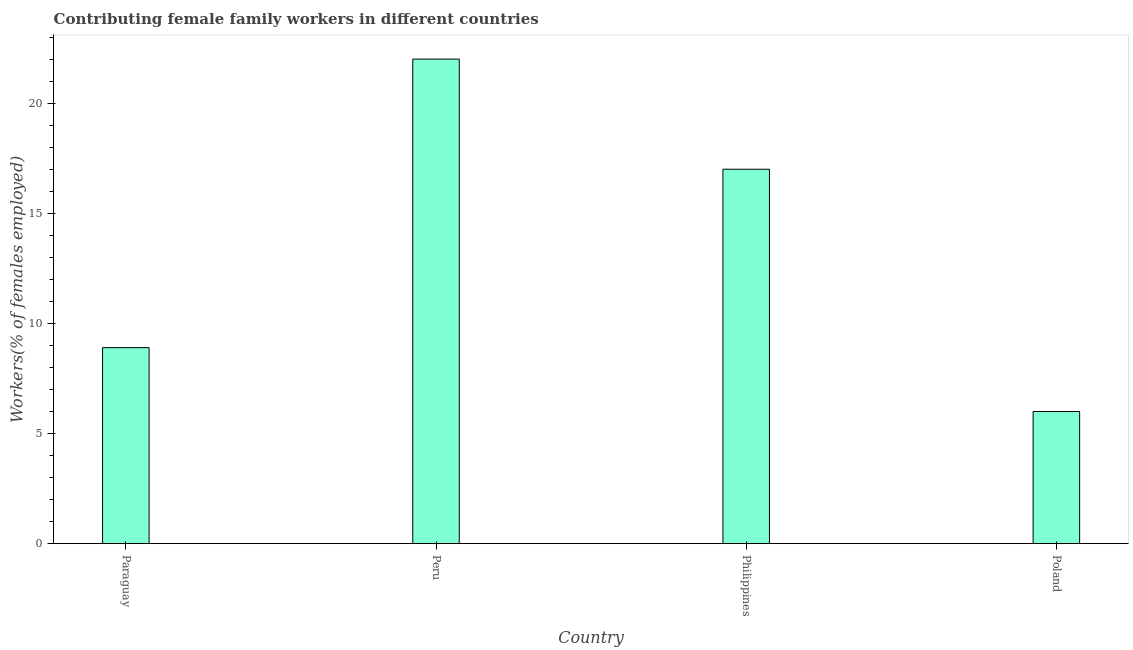Does the graph contain any zero values?
Offer a terse response. No. What is the title of the graph?
Provide a short and direct response. Contributing female family workers in different countries. What is the label or title of the X-axis?
Provide a short and direct response. Country. What is the label or title of the Y-axis?
Give a very brief answer. Workers(% of females employed). What is the contributing female family workers in Paraguay?
Your response must be concise. 8.9. Across all countries, what is the maximum contributing female family workers?
Offer a very short reply. 22. In which country was the contributing female family workers maximum?
Keep it short and to the point. Peru. What is the sum of the contributing female family workers?
Make the answer very short. 53.9. What is the difference between the contributing female family workers in Paraguay and Philippines?
Keep it short and to the point. -8.1. What is the average contributing female family workers per country?
Keep it short and to the point. 13.47. What is the median contributing female family workers?
Your answer should be compact. 12.95. What is the ratio of the contributing female family workers in Peru to that in Poland?
Your answer should be compact. 3.67. Is the contributing female family workers in Paraguay less than that in Philippines?
Provide a short and direct response. Yes. Is the difference between the contributing female family workers in Paraguay and Philippines greater than the difference between any two countries?
Offer a terse response. No. What is the difference between the highest and the second highest contributing female family workers?
Make the answer very short. 5. Is the sum of the contributing female family workers in Peru and Poland greater than the maximum contributing female family workers across all countries?
Your answer should be compact. Yes. What is the difference between the highest and the lowest contributing female family workers?
Make the answer very short. 16. How many countries are there in the graph?
Provide a succinct answer. 4. What is the difference between two consecutive major ticks on the Y-axis?
Make the answer very short. 5. What is the Workers(% of females employed) in Paraguay?
Your response must be concise. 8.9. What is the Workers(% of females employed) in Philippines?
Ensure brevity in your answer.  17. What is the difference between the Workers(% of females employed) in Paraguay and Philippines?
Your response must be concise. -8.1. What is the difference between the Workers(% of females employed) in Paraguay and Poland?
Keep it short and to the point. 2.9. What is the difference between the Workers(% of females employed) in Peru and Poland?
Offer a very short reply. 16. What is the difference between the Workers(% of females employed) in Philippines and Poland?
Offer a very short reply. 11. What is the ratio of the Workers(% of females employed) in Paraguay to that in Peru?
Offer a very short reply. 0.41. What is the ratio of the Workers(% of females employed) in Paraguay to that in Philippines?
Give a very brief answer. 0.52. What is the ratio of the Workers(% of females employed) in Paraguay to that in Poland?
Ensure brevity in your answer.  1.48. What is the ratio of the Workers(% of females employed) in Peru to that in Philippines?
Ensure brevity in your answer.  1.29. What is the ratio of the Workers(% of females employed) in Peru to that in Poland?
Provide a succinct answer. 3.67. What is the ratio of the Workers(% of females employed) in Philippines to that in Poland?
Ensure brevity in your answer.  2.83. 